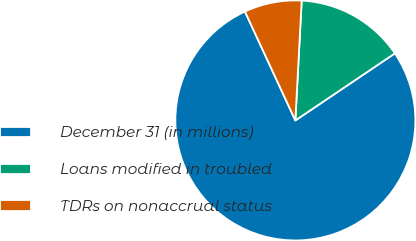<chart> <loc_0><loc_0><loc_500><loc_500><pie_chart><fcel>December 31 (in millions)<fcel>Loans modified in troubled<fcel>TDRs on nonaccrual status<nl><fcel>77.54%<fcel>14.72%<fcel>7.74%<nl></chart> 